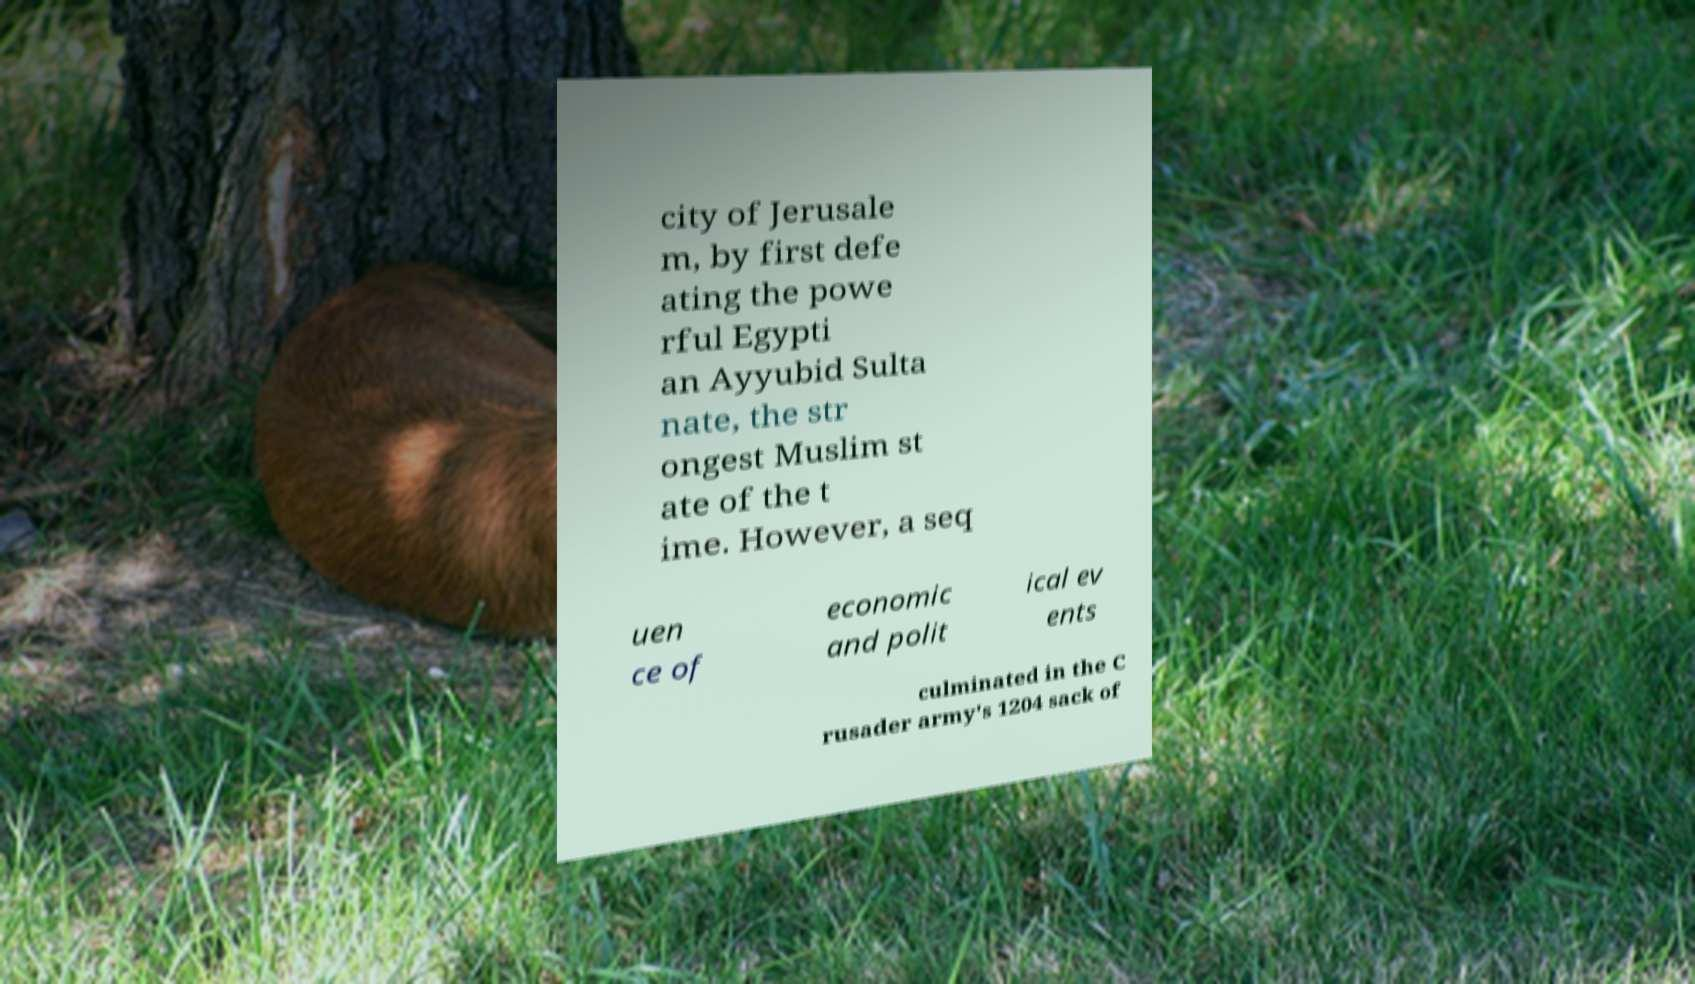Please read and relay the text visible in this image. What does it say? city of Jerusale m, by first defe ating the powe rful Egypti an Ayyubid Sulta nate, the str ongest Muslim st ate of the t ime. However, a seq uen ce of economic and polit ical ev ents culminated in the C rusader army's 1204 sack of 